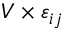<formula> <loc_0><loc_0><loc_500><loc_500>V \times \varepsilon _ { i j }</formula> 